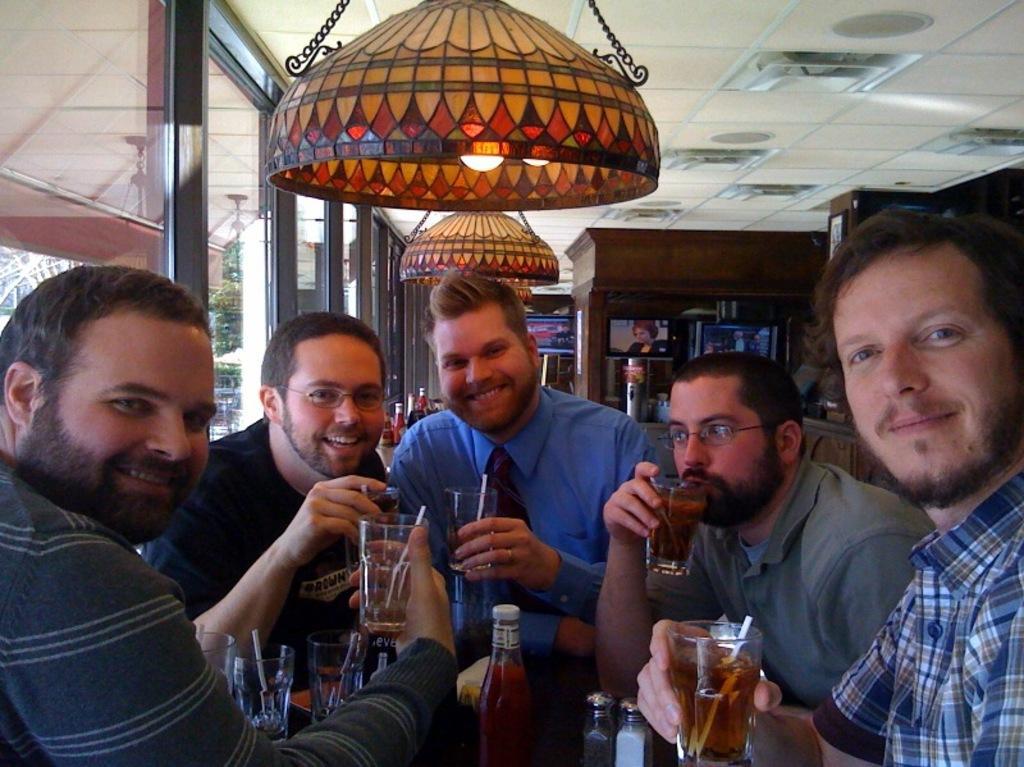In one or two sentences, can you explain what this image depicts? this picture shows group of men together with a smile on their faces and we see glasses in their hand and a light on the top. 